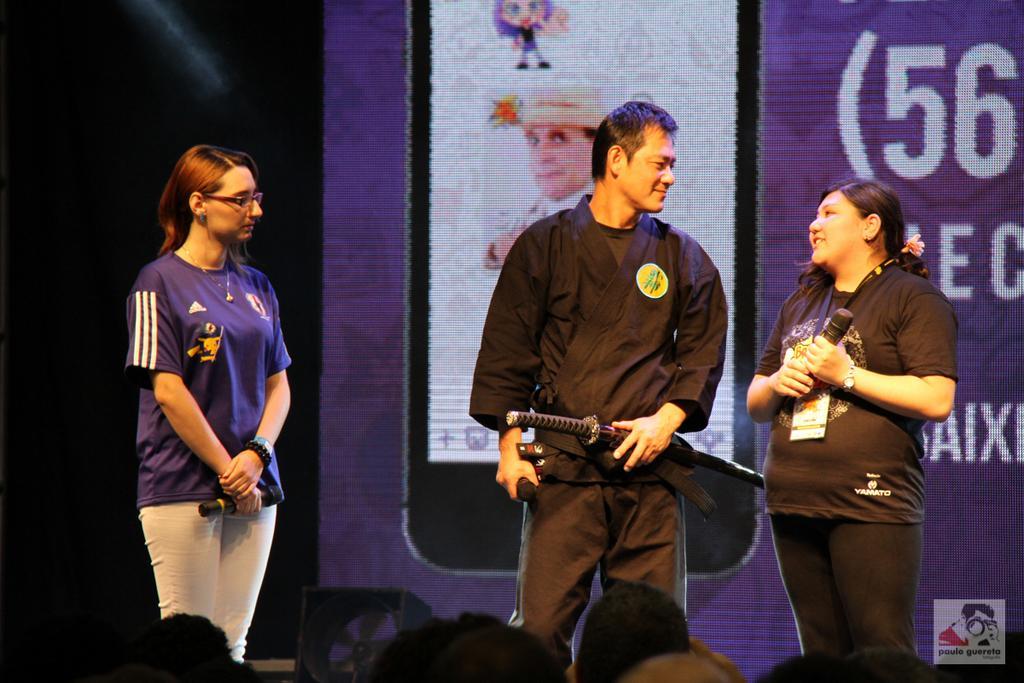In one or two sentences, can you explain what this image depicts? Here we can see two women and a man in the middle are standing by holding mics in their hands and the man is also holding a sword in his hand. At the bottom we can see few persons heads. In the background we can see a screen. 